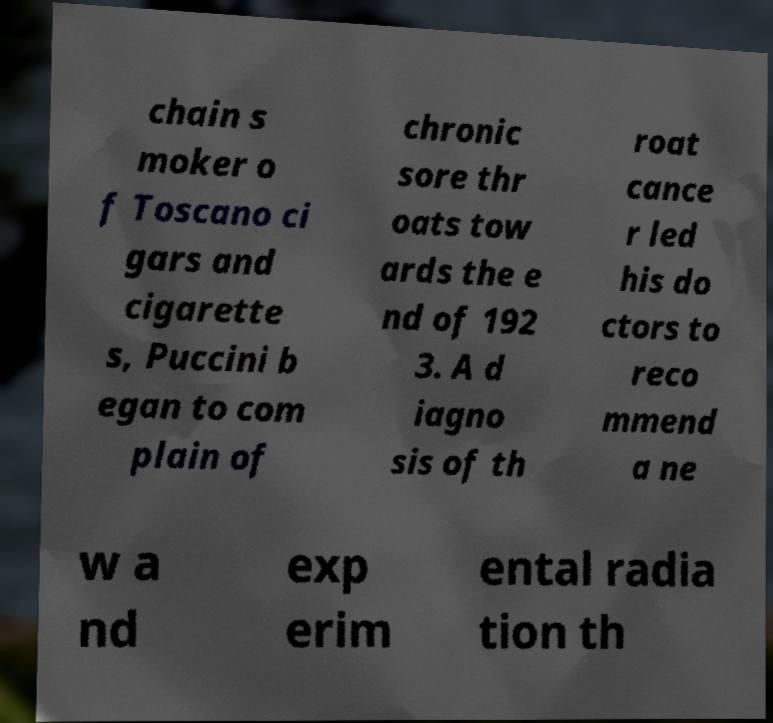Please read and relay the text visible in this image. What does it say? chain s moker o f Toscano ci gars and cigarette s, Puccini b egan to com plain of chronic sore thr oats tow ards the e nd of 192 3. A d iagno sis of th roat cance r led his do ctors to reco mmend a ne w a nd exp erim ental radia tion th 